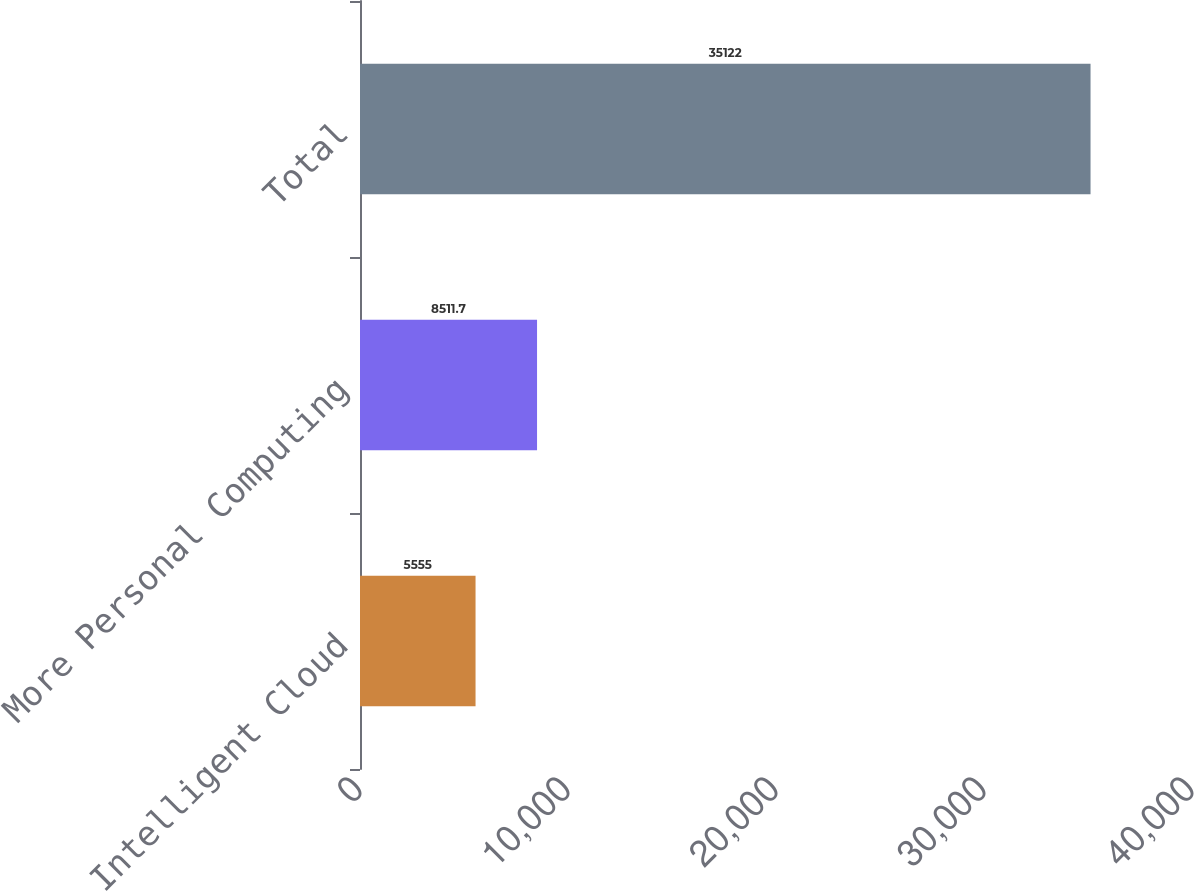Convert chart. <chart><loc_0><loc_0><loc_500><loc_500><bar_chart><fcel>Intelligent Cloud<fcel>More Personal Computing<fcel>Total<nl><fcel>5555<fcel>8511.7<fcel>35122<nl></chart> 